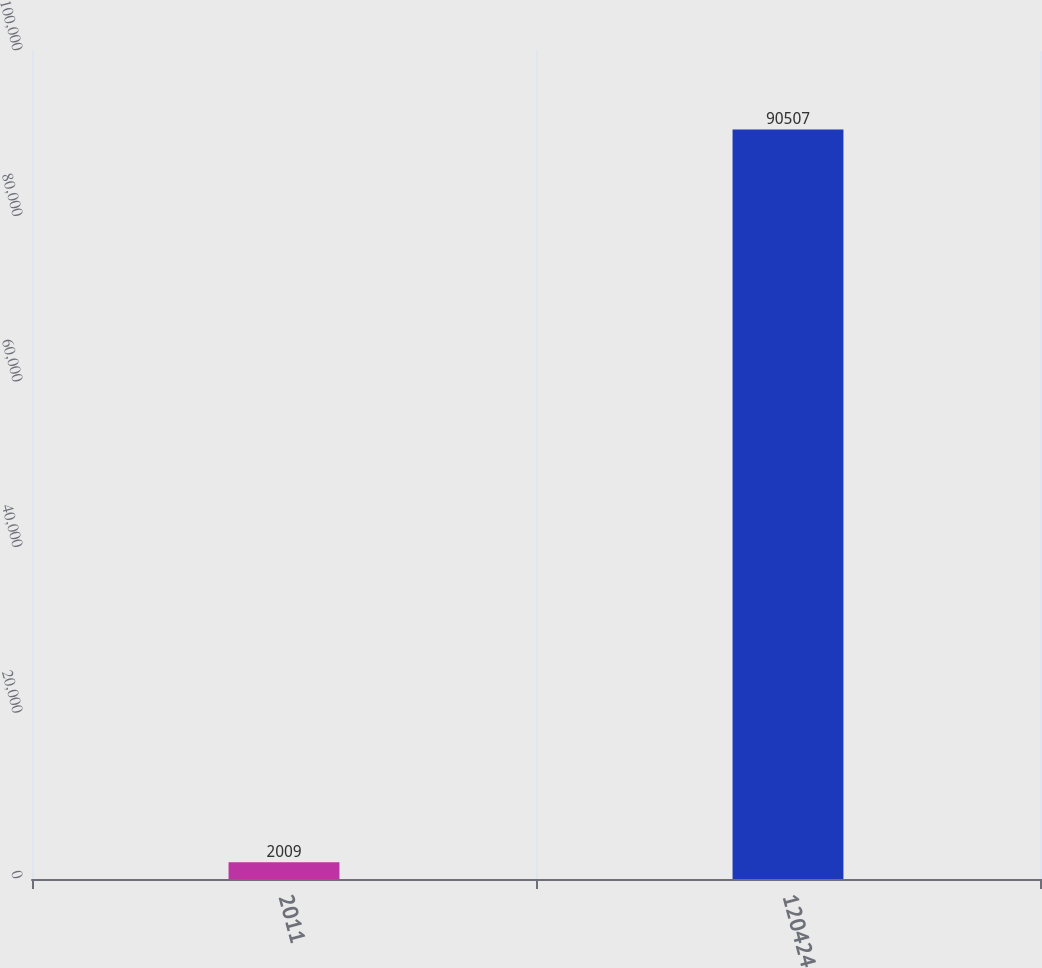Convert chart. <chart><loc_0><loc_0><loc_500><loc_500><bar_chart><fcel>2011<fcel>120424<nl><fcel>2009<fcel>90507<nl></chart> 